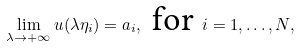Convert formula to latex. <formula><loc_0><loc_0><loc_500><loc_500>\lim _ { \lambda \to + \infty } u ( \lambda \eta _ { i } ) = a _ { i } , \text { for } i = 1 , \dots , N ,</formula> 